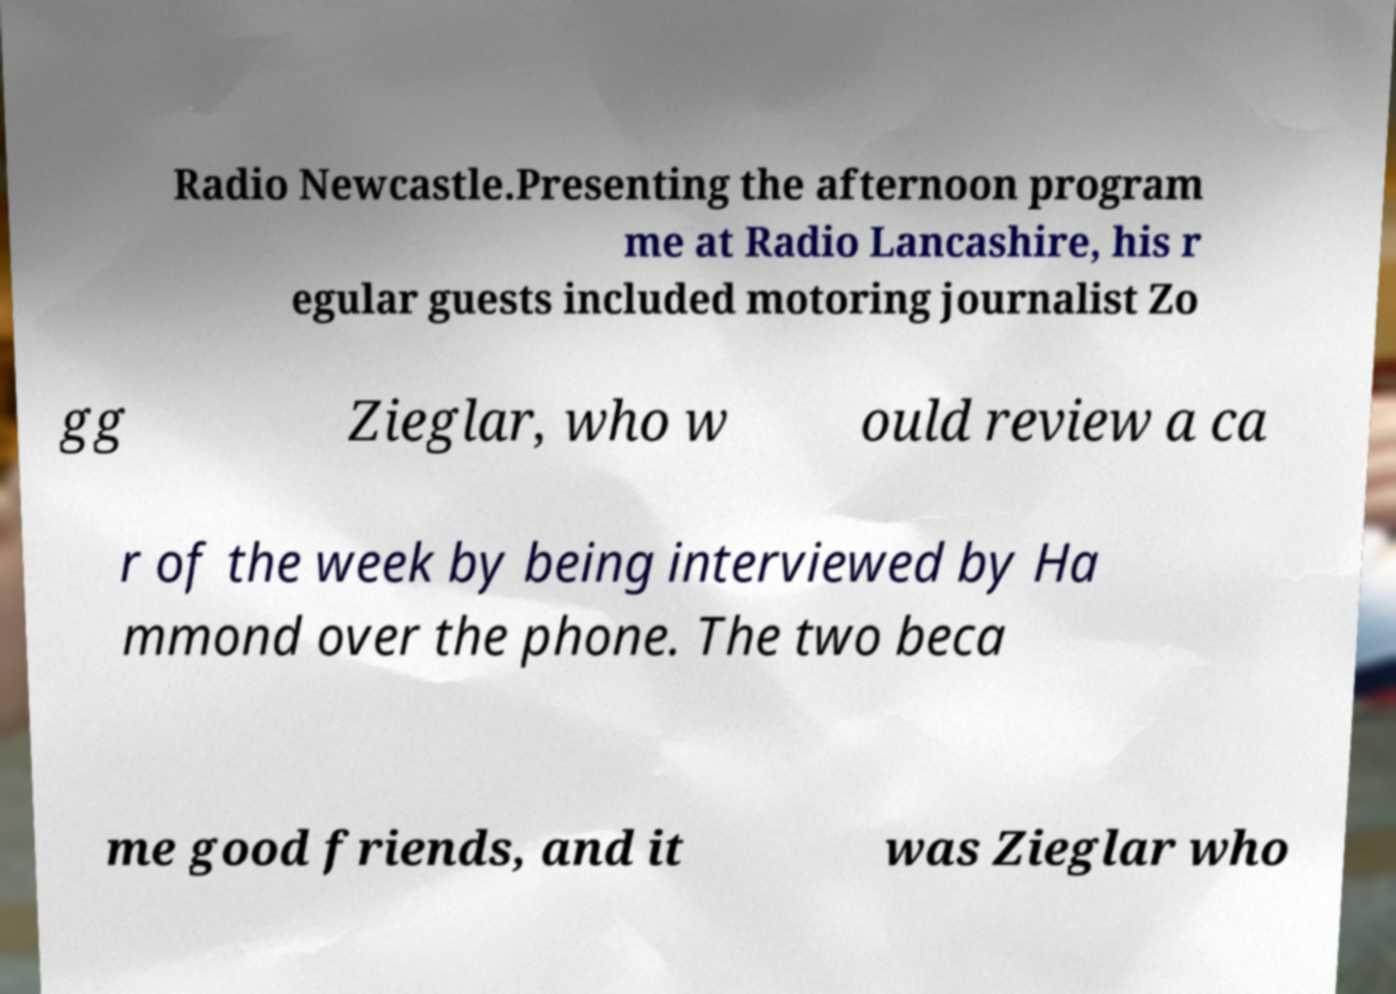Can you accurately transcribe the text from the provided image for me? Radio Newcastle.Presenting the afternoon program me at Radio Lancashire, his r egular guests included motoring journalist Zo gg Zieglar, who w ould review a ca r of the week by being interviewed by Ha mmond over the phone. The two beca me good friends, and it was Zieglar who 